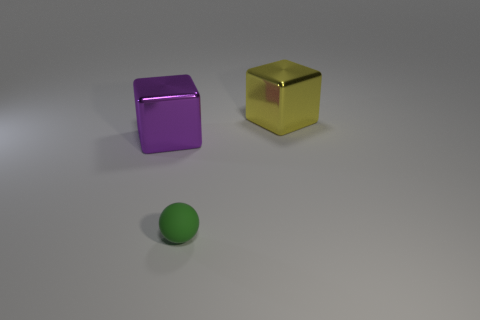Add 2 large gray spheres. How many objects exist? 5 Subtract all rubber balls. Subtract all yellow metallic things. How many objects are left? 1 Add 1 purple metallic blocks. How many purple metallic blocks are left? 2 Add 2 tiny spheres. How many tiny spheres exist? 3 Subtract all yellow cubes. How many cubes are left? 1 Subtract 0 brown spheres. How many objects are left? 3 Subtract all balls. How many objects are left? 2 Subtract 1 balls. How many balls are left? 0 Subtract all red cubes. Subtract all brown cylinders. How many cubes are left? 2 